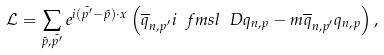<formula> <loc_0><loc_0><loc_500><loc_500>\mathcal { L } = \sum _ { \tilde { p } , \tilde { p ^ { \prime } } } e ^ { i ( \tilde { p ^ { \prime } } - \tilde { p } ) \cdot x } \left ( \overline { q } _ { n , p ^ { \prime } } i \ f m s l { \ D } q _ { n , p } - m \overline { q } _ { n , p ^ { \prime } } q _ { n , p } \right ) ,</formula> 